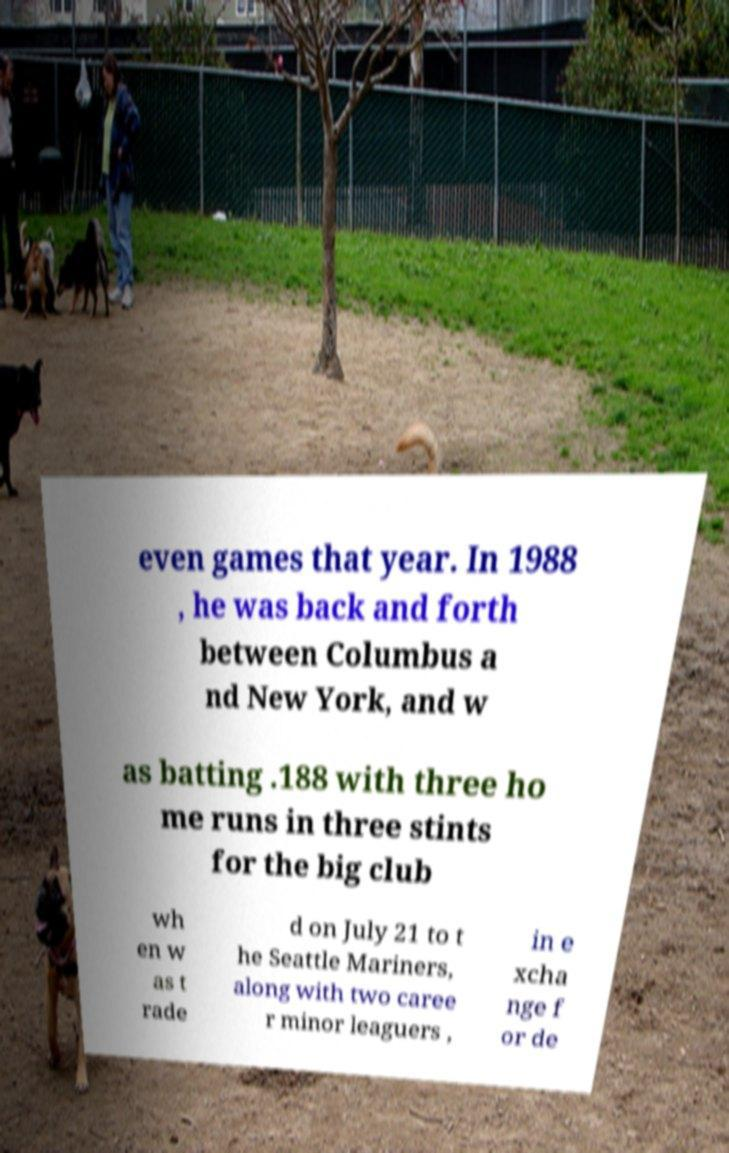Please read and relay the text visible in this image. What does it say? even games that year. In 1988 , he was back and forth between Columbus a nd New York, and w as batting .188 with three ho me runs in three stints for the big club wh en w as t rade d on July 21 to t he Seattle Mariners, along with two caree r minor leaguers , in e xcha nge f or de 